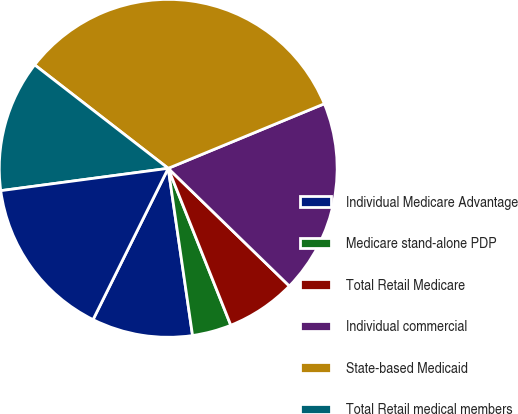Convert chart to OTSL. <chart><loc_0><loc_0><loc_500><loc_500><pie_chart><fcel>Individual Medicare Advantage<fcel>Medicare stand-alone PDP<fcel>Total Retail Medicare<fcel>Individual commercial<fcel>State-based Medicaid<fcel>Total Retail medical members<fcel>Individual specialty<nl><fcel>9.64%<fcel>3.74%<fcel>6.69%<fcel>18.51%<fcel>33.27%<fcel>12.6%<fcel>15.55%<nl></chart> 